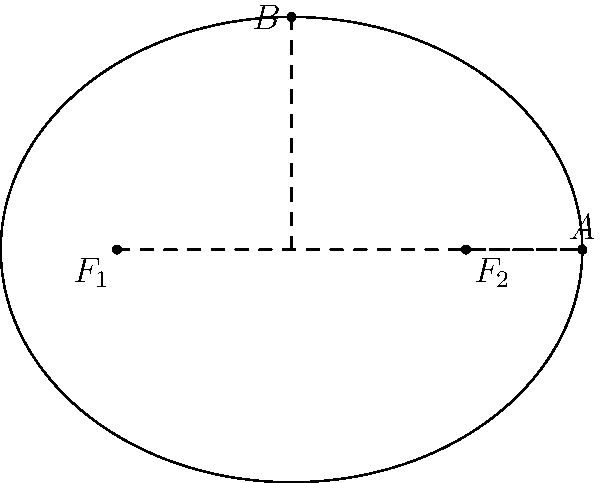In the ellipse shown above, points $F_1$ and $F_2$ are the foci, and points $A$ and $B$ lie on the ellipse. Given that the distance between the foci is 6 units and the length of the semi-major axis (OA) is 5 units, calculate the eccentricity of the ellipse. Let's approach this step-by-step:

1) First, recall the formula for eccentricity: $e = \frac{c}{a}$, where $c$ is half the distance between the foci, and $a$ is the length of the semi-major axis.

2) We're given that the distance between the foci is 6 units. So, $c = 3$ units.

3) We're also given that the length of the semi-major axis (OA) is 5 units. So, $a = 5$ units.

4) Now we can substitute these values into our eccentricity formula:

   $e = \frac{c}{a} = \frac{3}{5} = 0.6$

5) To verify, we can check if this satisfies the ellipse equation:
   $b^2 = a^2 - c^2$, where $b$ is the length of the semi-minor axis.

   $b^2 = 5^2 - 3^2 = 25 - 9 = 16$
   $b = 4$

   This checks out with our diagram, confirming our calculation.
Answer: $0.6$ 